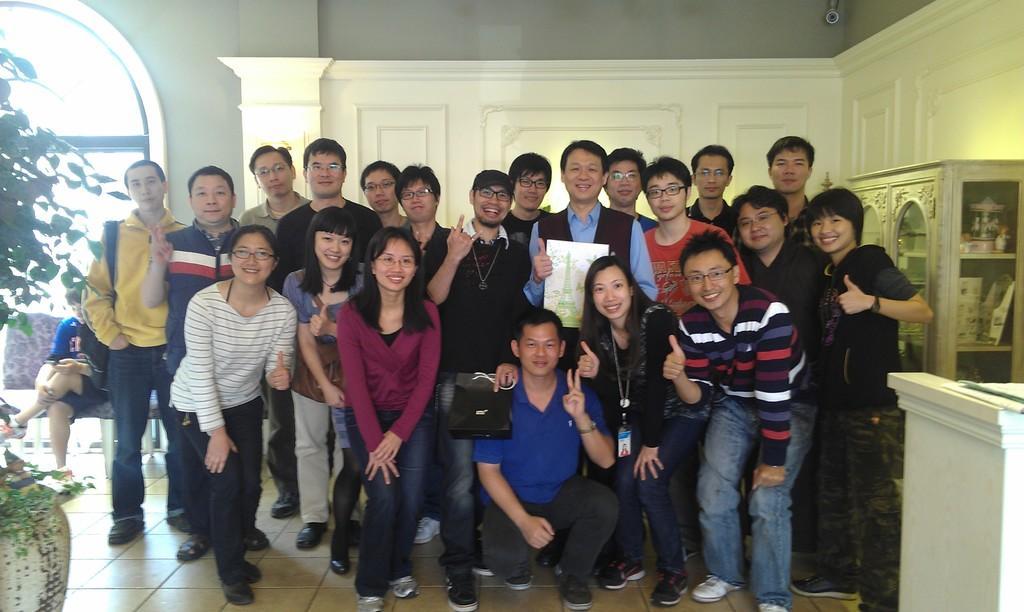In one or two sentences, can you explain what this image depicts? In the picture we can see a group of boys and girls are standing and beside them, we can see some showcase rack and on the other side, we can see some plants and one person sitting on the chair. 